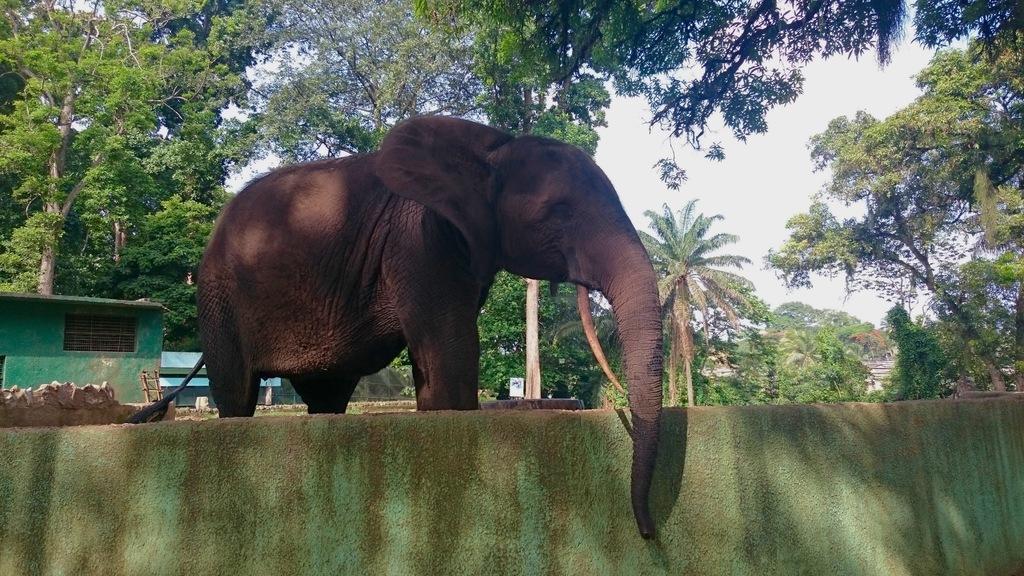Describe this image in one or two sentences. In this image we can see an elephant which is standing behind wall and at the background of the image there are some houses, trees and clear sky. 